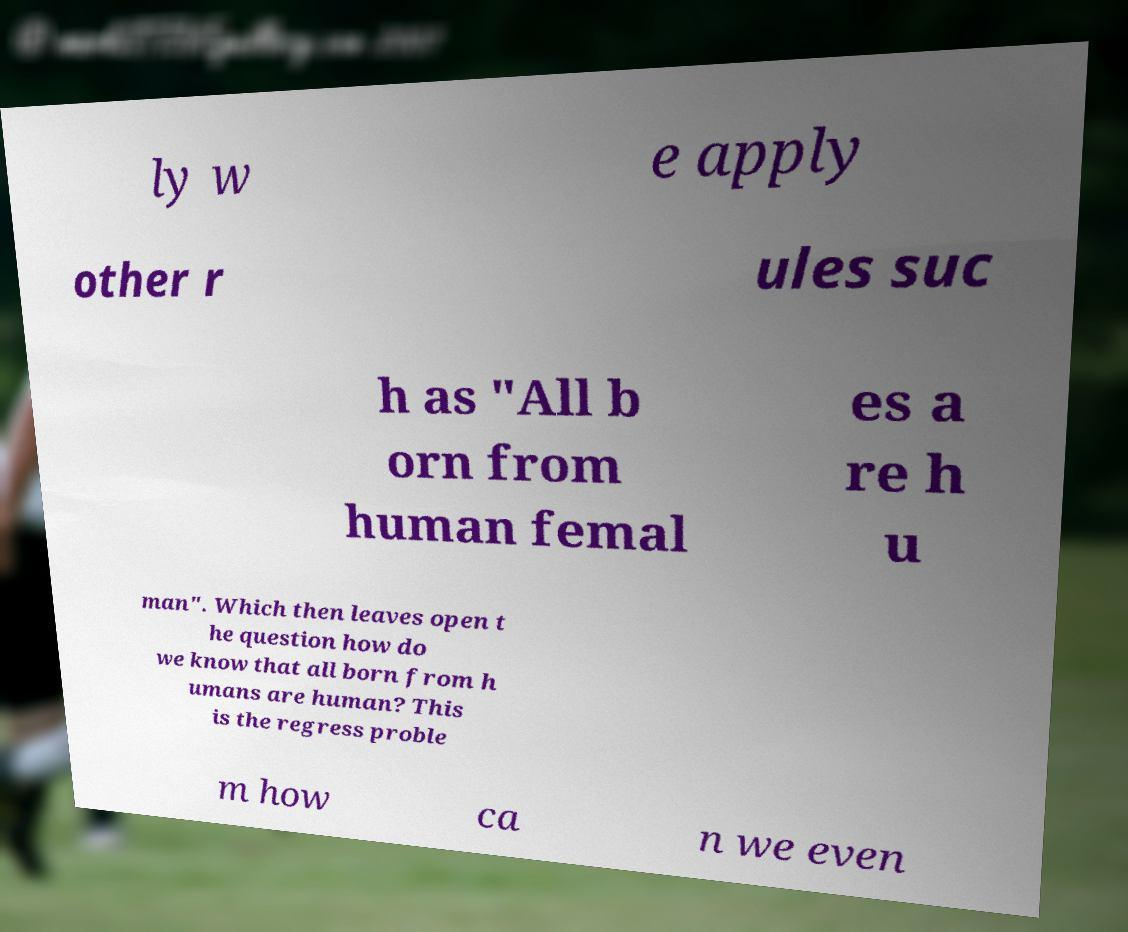I need the written content from this picture converted into text. Can you do that? ly w e apply other r ules suc h as "All b orn from human femal es a re h u man". Which then leaves open t he question how do we know that all born from h umans are human? This is the regress proble m how ca n we even 